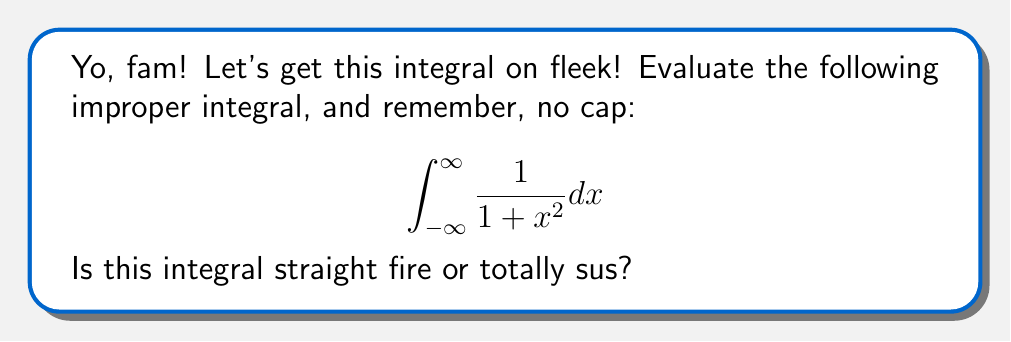Could you help me with this problem? Alright, let's break this down step-by-step, no cap:

1) First, we need to recognize that this is an improper integral because the limits of integration are infinite. It's totally sus, but we can handle it!

2) To evaluate this integral, we'll use the limit definition of improper integrals:

   $$ \lim_{a \to -\infty} \lim_{b \to \infty} \int_{a}^{b} \frac{1}{1 + x^2} dx $$

3) Now, we need to find the antiderivative. The antiderivative of $\frac{1}{1 + x^2}$ is $\arctan(x)$. That's straight fire!

4) Apply the Fundamental Theorem of Calculus:

   $$ \lim_{a \to -\infty} \lim_{b \to \infty} [\arctan(x)]_{a}^{b} $$

5) Evaluate the limits:

   $$ \lim_{a \to -\infty} \lim_{b \to \infty} [\arctan(b) - \arctan(a)] $$

6) As $b \to \infty$, $\arctan(b) \to \frac{\pi}{2}$
   As $a \to -\infty$, $\arctan(a) \to -\frac{\pi}{2}$

7) Therefore, the result is:

   $$ \frac{\pi}{2} - (-\frac{\pi}{2}) = \pi $$

And that's the tea, sis!
Answer: $\pi$ 